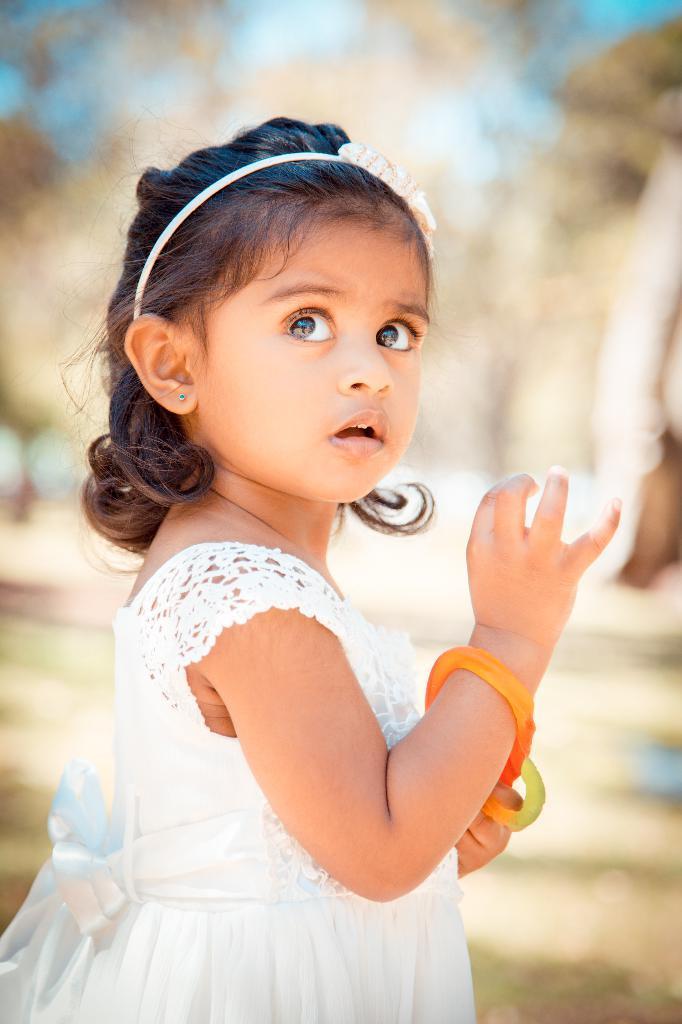How would you summarize this image in a sentence or two? In this image we can see a girl child. She is wearing bangles and hair band. In the background it is blur. 